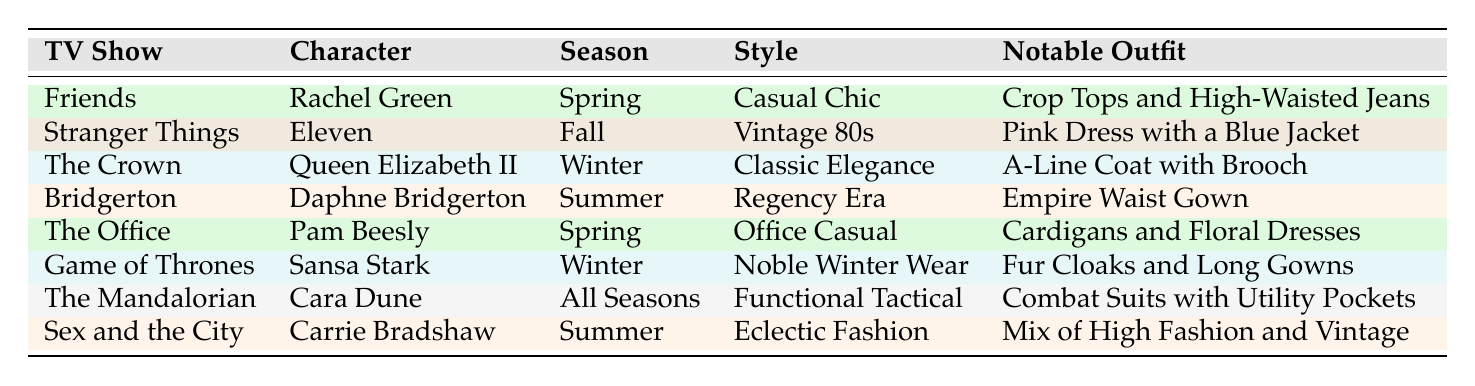What is the notable outfit of Rachel Green from Friends? The table lists Rachel Green from Friends under the Spring season with the style "Casual Chic." Her notable outfit is stated as "Crop Tops and High-Waisted Jeans."
Answer: Crop Tops and High-Waisted Jeans Which character is associated with the Classic Elegance style? Referring to the table, Queen Elizabeth II from The Crown is associated with the style "Classic Elegance," which is specified in the Winter season.
Answer: Queen Elizabeth II How many characters have a notable outfit that involves wearing dresses? The notable outfits of the characters include: Rachel Green with Crop Tops and High-Waisted Jeans, Eleven with a Pink Dress with a Blue Jacket, Pam Beesly with Cardigans and Floral Dresses, Daphne Bridgerton with an Empire Waist Gown, and Carrie Bradshaw with a mix of high fashion and vintage. There are four characters (Eleven, Pam Beesly, Daphne Bridgerton, Carrie Bradshaw) who have notable outfits that involve wearing dresses.
Answer: 4 Is there any character listed who wears outfits suitable for all seasons? In the table, Cara Dune from The Mandalorian is listed under "All Seasons" with the style "Functional Tactical." This indicates that she has outfits suitable for all seasons.
Answer: Yes What is the difference in the number of characters from Spring and Winter seasons? Counting the characters, there are 2 characters associated with Spring (Rachel Green and Pam Beesly) and 2 characters associated with Winter (Queen Elizabeth II and Sansa Stark). The difference between the two is 2 - 2 = 0.
Answer: 0 Which character from Bridgerton has a summer outfit? The table shows that Daphne Bridgerton from Bridgerton has a notable summer outfit described as "Empire Waist Gown."
Answer: Daphne Bridgerton Are there more characters with notable outfits in Summer than in Fall? In the table, there are 2 characters in Summer (Daphne Bridgerton and Carrie Bradshaw) and only 1 character in Fall (Eleven). So, there are more characters with notable outfits in Summer.
Answer: Yes What is the style of Sansa Stark from Game of Thrones, and what is her notable outfit? Sansa Stark from Game of Thrones is listed in the Winter season with the style "Noble Winter Wear." Her notable outfit is described as "Fur Cloaks and Long Gowns."
Answer: Noble Winter Wear; Fur Cloaks and Long Gowns Which famous TV show features a character known for Eclectic Fashion? The table states that Carrie Bradshaw from Sex and the City is associated with the style "Eclectic Fashion." Therefore, the show featuring her is Sex and the City.
Answer: Sex and the City 